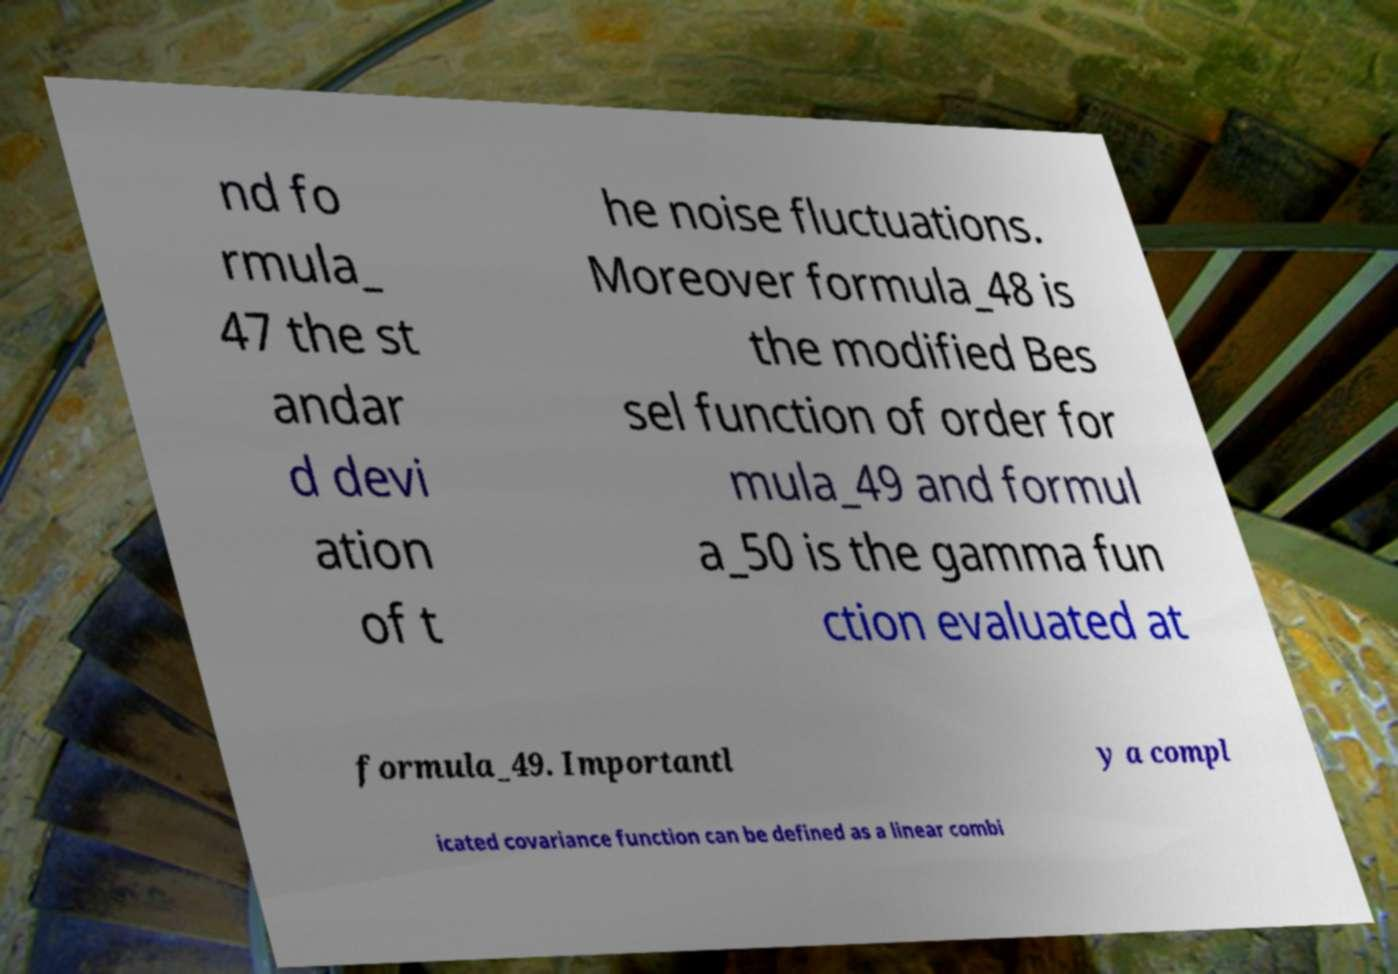Could you assist in decoding the text presented in this image and type it out clearly? nd fo rmula_ 47 the st andar d devi ation of t he noise fluctuations. Moreover formula_48 is the modified Bes sel function of order for mula_49 and formul a_50 is the gamma fun ction evaluated at formula_49. Importantl y a compl icated covariance function can be defined as a linear combi 